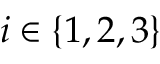<formula> <loc_0><loc_0><loc_500><loc_500>i \in \{ 1 , 2 , 3 \}</formula> 